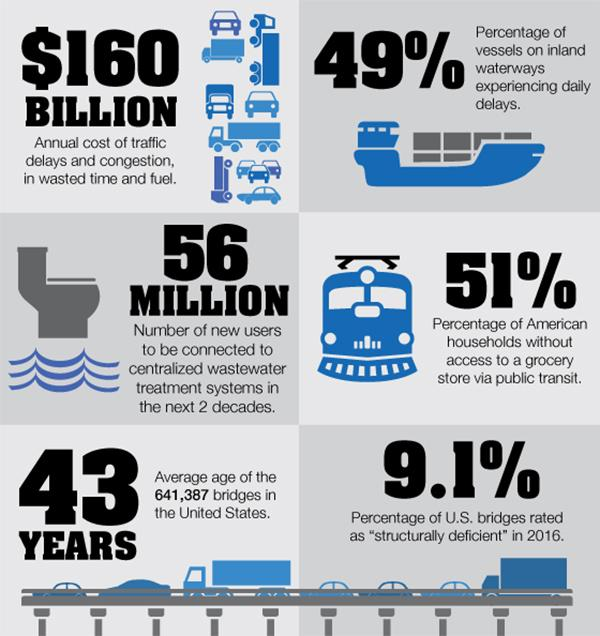Specify some key components in this picture. The annual cost of traffic delays and congestion is estimated to be $160 billion, resulting in wasted time and fuel. According to a recent survey, 49% of American households have access to a grocery store via public transit. 